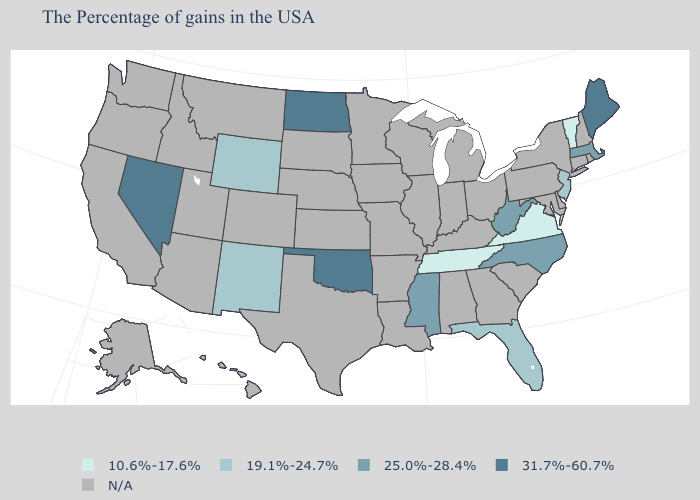What is the value of Florida?
Keep it brief. 19.1%-24.7%. What is the lowest value in states that border Mississippi?
Answer briefly. 10.6%-17.6%. How many symbols are there in the legend?
Quick response, please. 5. Is the legend a continuous bar?
Answer briefly. No. Name the states that have a value in the range N/A?
Write a very short answer. Rhode Island, New Hampshire, Connecticut, New York, Delaware, Maryland, Pennsylvania, South Carolina, Ohio, Georgia, Michigan, Kentucky, Indiana, Alabama, Wisconsin, Illinois, Louisiana, Missouri, Arkansas, Minnesota, Iowa, Kansas, Nebraska, Texas, South Dakota, Colorado, Utah, Montana, Arizona, Idaho, California, Washington, Oregon, Alaska, Hawaii. Which states hav the highest value in the South?
Give a very brief answer. Oklahoma. Among the states that border Maryland , does West Virginia have the lowest value?
Write a very short answer. No. Name the states that have a value in the range N/A?
Concise answer only. Rhode Island, New Hampshire, Connecticut, New York, Delaware, Maryland, Pennsylvania, South Carolina, Ohio, Georgia, Michigan, Kentucky, Indiana, Alabama, Wisconsin, Illinois, Louisiana, Missouri, Arkansas, Minnesota, Iowa, Kansas, Nebraska, Texas, South Dakota, Colorado, Utah, Montana, Arizona, Idaho, California, Washington, Oregon, Alaska, Hawaii. Name the states that have a value in the range 10.6%-17.6%?
Keep it brief. Vermont, Virginia, Tennessee. Which states hav the highest value in the MidWest?
Be succinct. North Dakota. Name the states that have a value in the range 25.0%-28.4%?
Answer briefly. Massachusetts, North Carolina, West Virginia, Mississippi. 